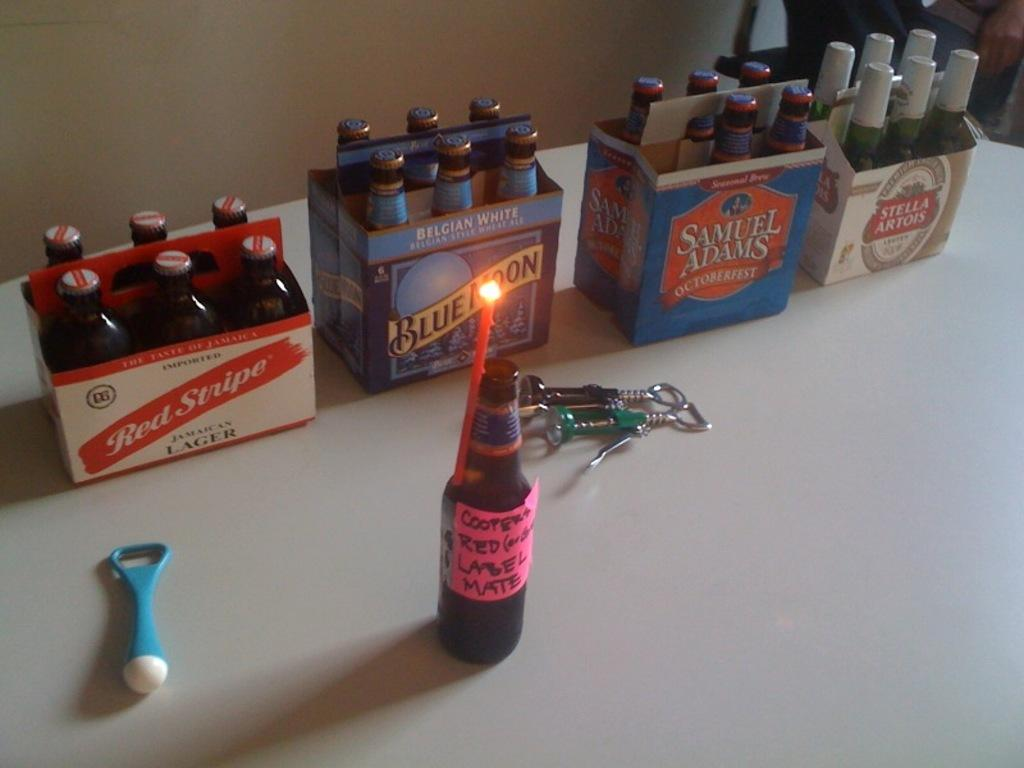<image>
Offer a succinct explanation of the picture presented. A six pack of Red Stripe bottle sits next to a six pack of Blue Moon beer. 